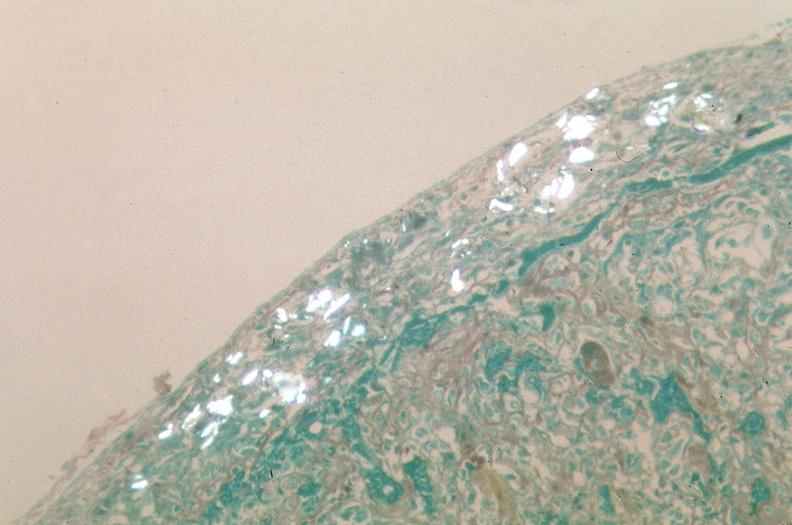what was talc used, alpha-1 antitrypsin deficiency?
Answer the question using a single word or phrase. Used to sclerose emphysematous lung 